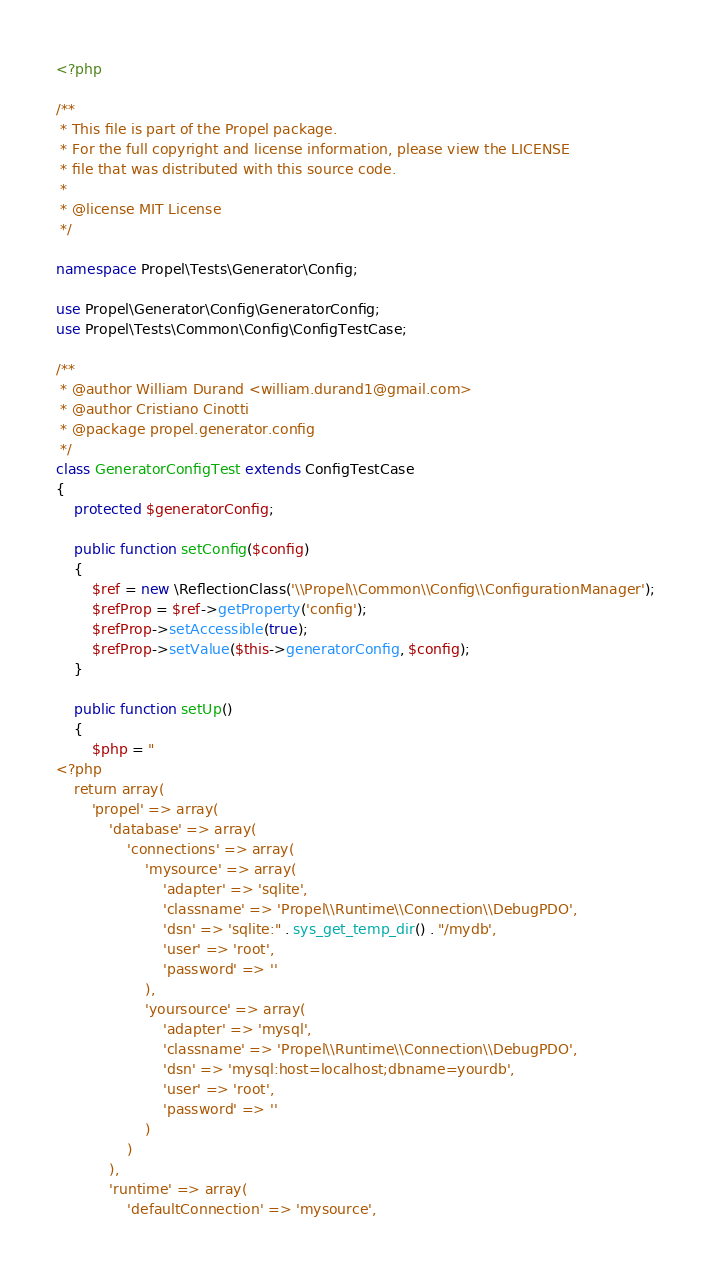<code> <loc_0><loc_0><loc_500><loc_500><_PHP_><?php

/**
 * This file is part of the Propel package.
 * For the full copyright and license information, please view the LICENSE
 * file that was distributed with this source code.
 *
 * @license MIT License
 */

namespace Propel\Tests\Generator\Config;

use Propel\Generator\Config\GeneratorConfig;
use Propel\Tests\Common\Config\ConfigTestCase;

/**
 * @author William Durand <william.durand1@gmail.com>
 * @author Cristiano Cinotti
 * @package	propel.generator.config
 */
class GeneratorConfigTest extends ConfigTestCase
{
    protected $generatorConfig;

    public function setConfig($config)
    {
        $ref = new \ReflectionClass('\\Propel\\Common\\Config\\ConfigurationManager');
        $refProp = $ref->getProperty('config');
        $refProp->setAccessible(true);
        $refProp->setValue($this->generatorConfig, $config);
    }

    public function setUp()
    {
        $php = "
<?php
    return array(
        'propel' => array(
            'database' => array(
                'connections' => array(
                    'mysource' => array(
                        'adapter' => 'sqlite',
                        'classname' => 'Propel\\Runtime\\Connection\\DebugPDO',
                        'dsn' => 'sqlite:" . sys_get_temp_dir() . "/mydb',
                        'user' => 'root',
                        'password' => ''
                    ),
                    'yoursource' => array(
                        'adapter' => 'mysql',
                        'classname' => 'Propel\\Runtime\\Connection\\DebugPDO',
                        'dsn' => 'mysql:host=localhost;dbname=yourdb',
                        'user' => 'root',
                        'password' => ''
                    )
                )
            ),
            'runtime' => array(
                'defaultConnection' => 'mysource',</code> 